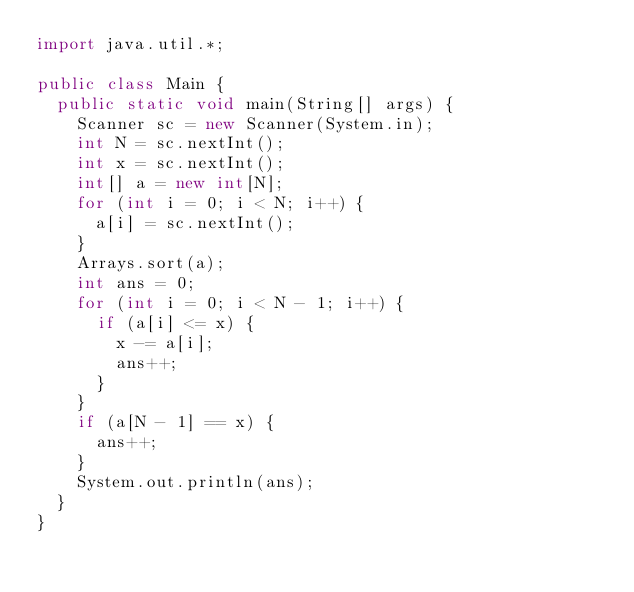<code> <loc_0><loc_0><loc_500><loc_500><_Java_>import java.util.*;

public class Main {
  public static void main(String[] args) {
    Scanner sc = new Scanner(System.in);
    int N = sc.nextInt();
    int x = sc.nextInt();
    int[] a = new int[N];
    for (int i = 0; i < N; i++) {
      a[i] = sc.nextInt();
    }
    Arrays.sort(a);
    int ans = 0;
    for (int i = 0; i < N - 1; i++) {
      if (a[i] <= x) {
        x -= a[i];
        ans++;
      }
    }
    if (a[N - 1] == x) {
      ans++;
    }
    System.out.println(ans);
  }
}</code> 